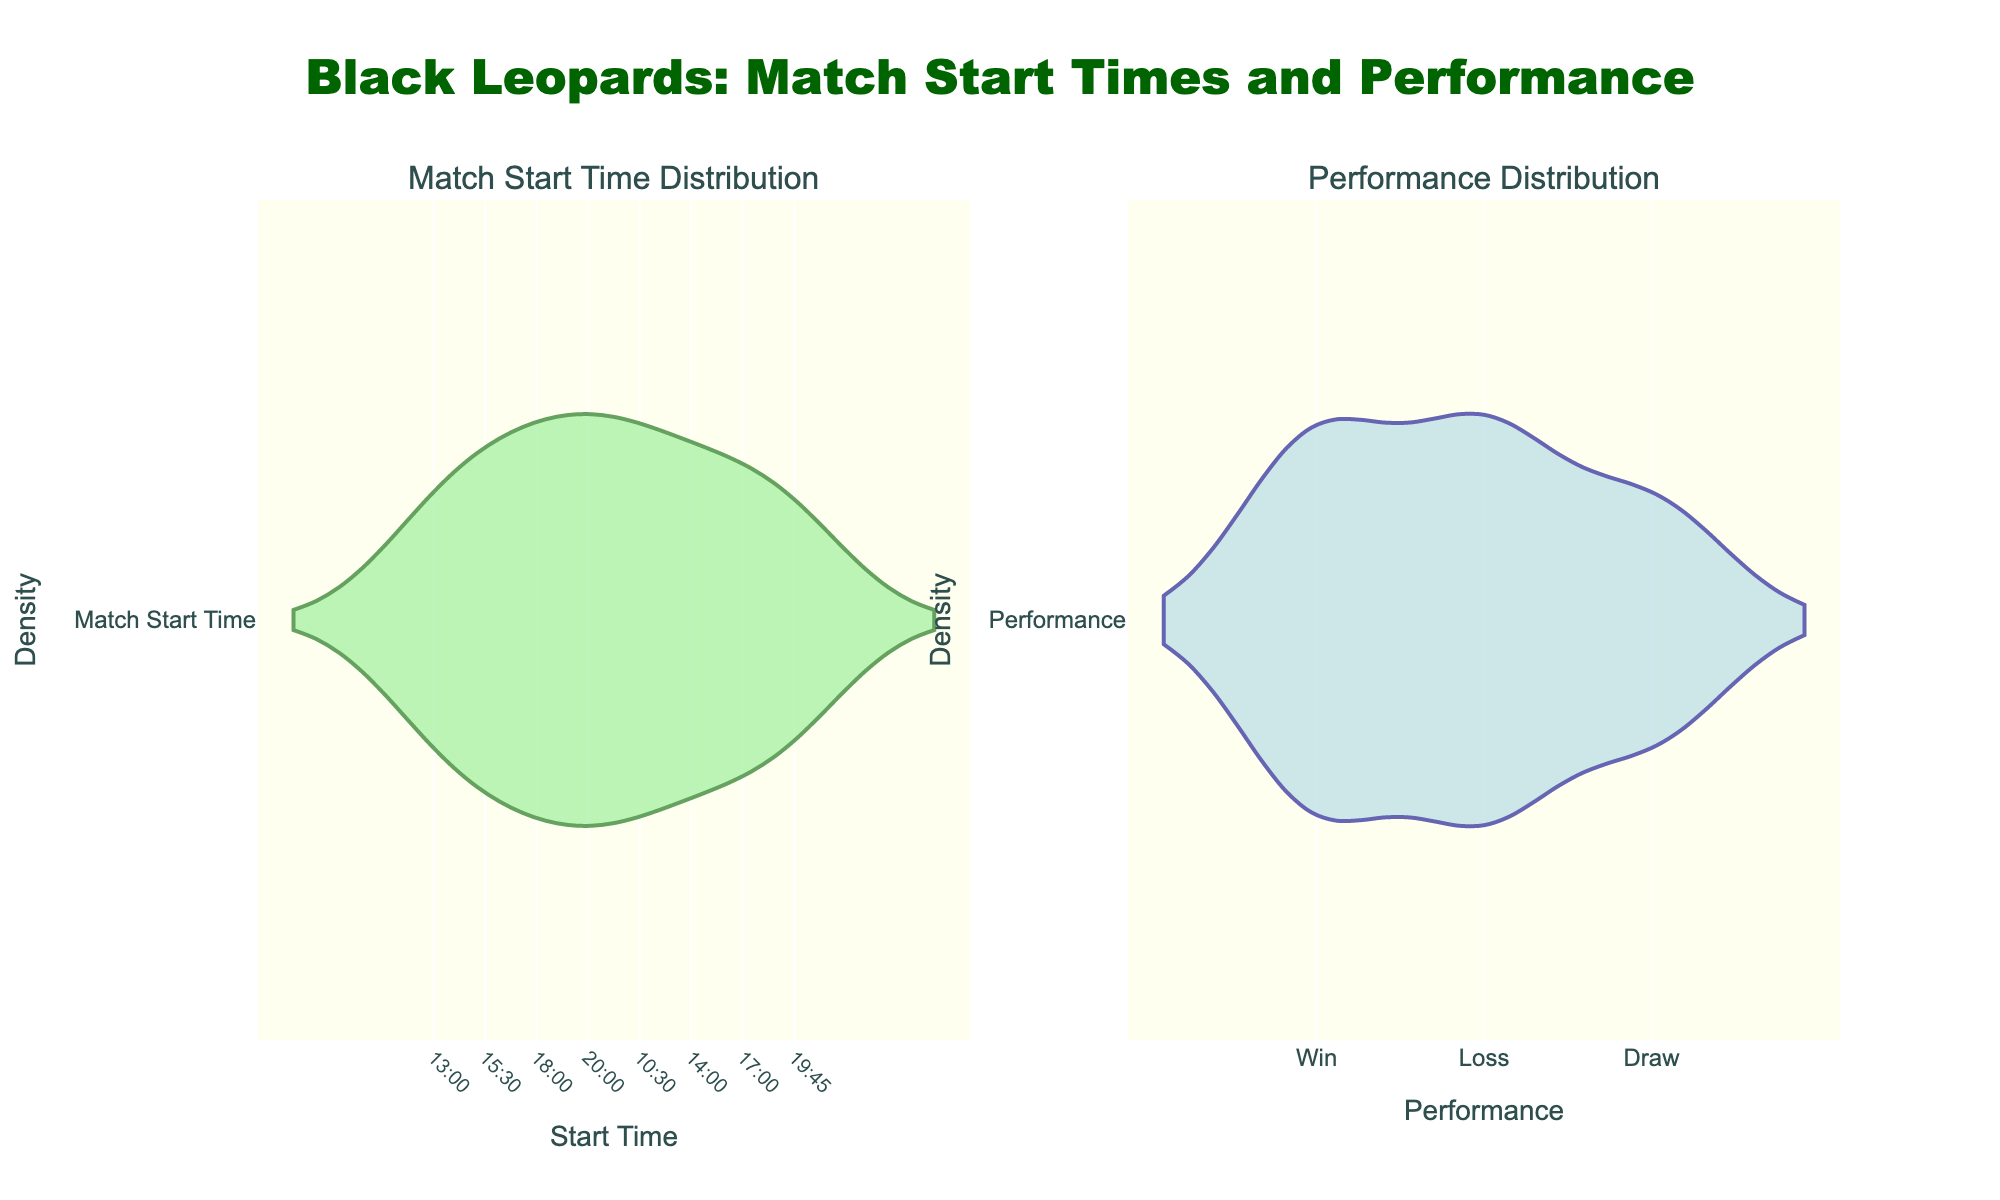what is the title of the figure? The title is written at the top of the figure and it typically summarizes the purpose or main insight of the plot.
Answer: Black Leopards: Match Start Times and Performance What are the labels of the x-axes in the figure? The x-axes labels are found along the bottom of each subplot, indicating what the data along those axes represent.
Answer: Start Time (left), Performance (right) What color is used for the Match Start Time density plot? The color of the Match Start Time density plot is mentioned in the explanation of the plot features.
Answer: Light green What times are included in the Match Start Time distribution? The x-axis of the Match Start Time density plot shows the different start times included in the data.
Answer: 10:30, 13:00, 14:00, 15:30, 17:00, 18:00, 19:45, 20:00 What performance outcome appears to have the highest density? To determine this, one can look at the density in the Performance density plot and see which performance has the highest peak.
Answer: Win Which match start time appears most frequent in the data? By observing the peaks on the Match Start Time density plot, one can determine which time has the highest density.
Answer: 20:00 Which has a higher density in the Performance plot: Win or Loss? By comparing the peaks of the density curves in the Performance plot for Win and Loss, one can see which is higher.
Answer: Win Are there more matches starting at 17:00 or 19:45? By comparing the densities at these two times in the Match Start Time density plot, we can see which time has more matches.
Answer: 19:45 Based on the plot, during which time slots does Black Leopards performance tend to win more often? By cross-referencing the peaks in the Match Start Time plot with those in the Performance plot, one can deduce the times associated with higher win densities.
Answer: 20:00, 15:30, 17:00 What is the primary visual difference between the two subplots? The primary visual difference between the two subplots can be described in terms of their main features such as color, density distributions, and what is being measured on the x-axes.
Answer: The left subplot shows the distribution of match start times in light green, while the right subplot shows the performance distribution in light blue 